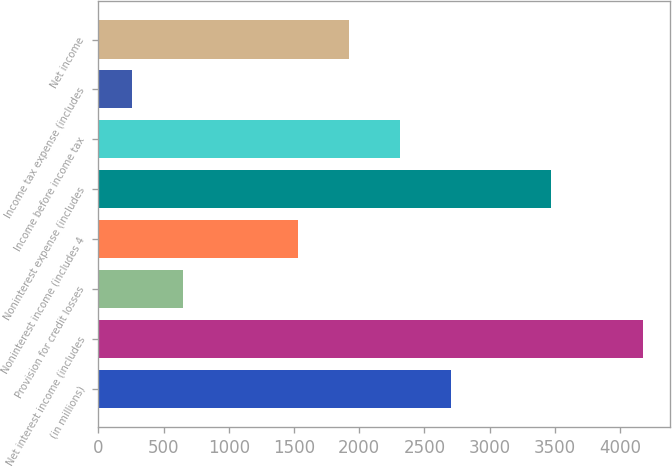<chart> <loc_0><loc_0><loc_500><loc_500><bar_chart><fcel>(in millions)<fcel>Net interest income (includes<fcel>Provision for credit losses<fcel>Noninterest income (includes 4<fcel>Noninterest expense (includes<fcel>Income before income tax<fcel>Income tax expense (includes<fcel>Net income<nl><fcel>2707.9<fcel>4173<fcel>651.3<fcel>1534<fcel>3474<fcel>2316.6<fcel>260<fcel>1925.3<nl></chart> 